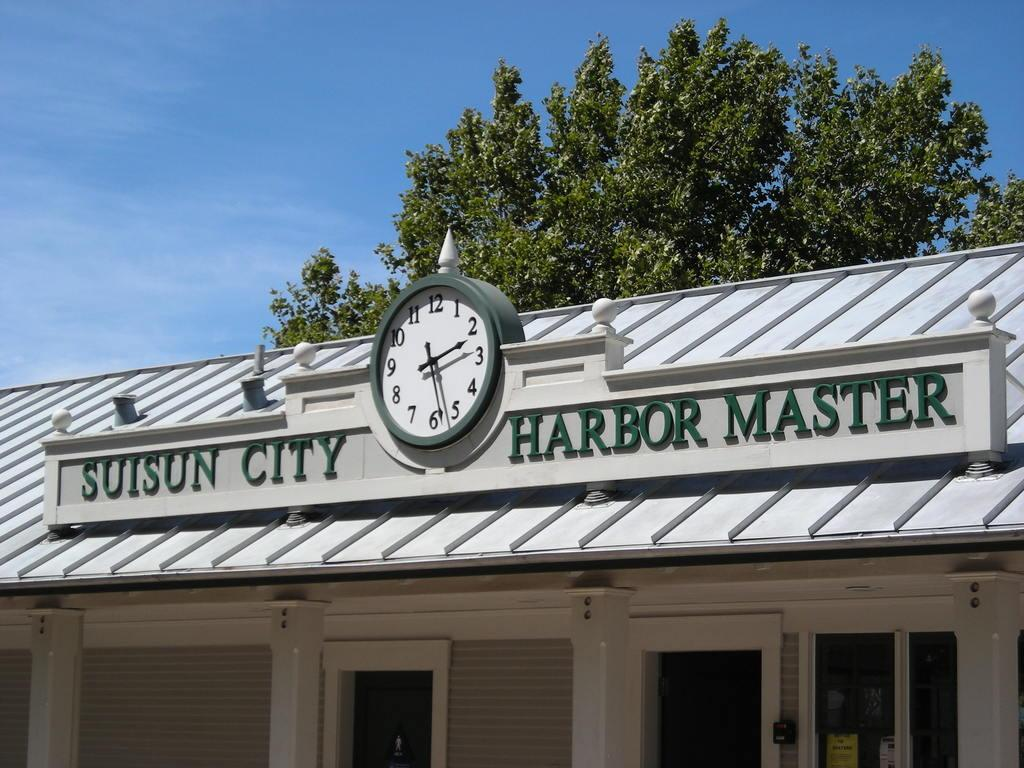<image>
Share a concise interpretation of the image provided. A clock tops the Suisun City Harbor Master building. 